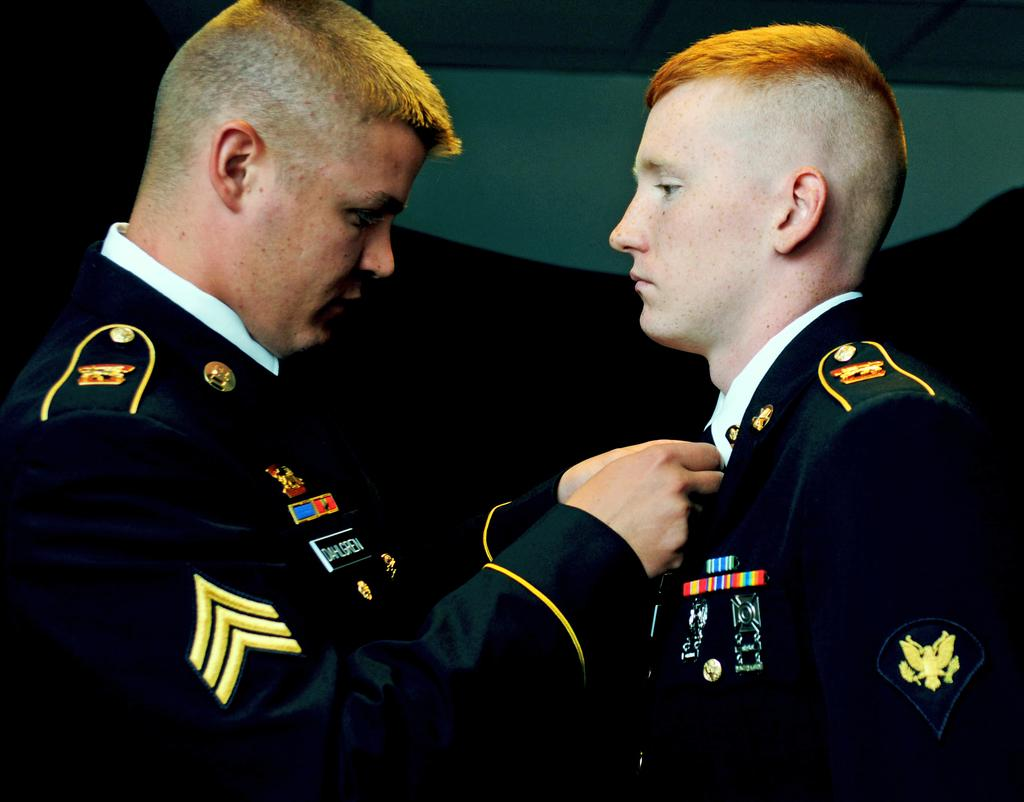How many people are in the image? There are two men in the image. What are the men doing in the image? The men are standing, and one man is holding the tie of the other man. What type of clothing are the men wearing? Both men are wearing coats. What can be seen on the men's clothing? There are badges visible in the image. What is the background of the image? There is a white wall in the background. What type of cloth is being used to help the man with his tie in the image? There is no cloth being used to help the man with his tie in the image; one man is simply holding the other man's tie. 